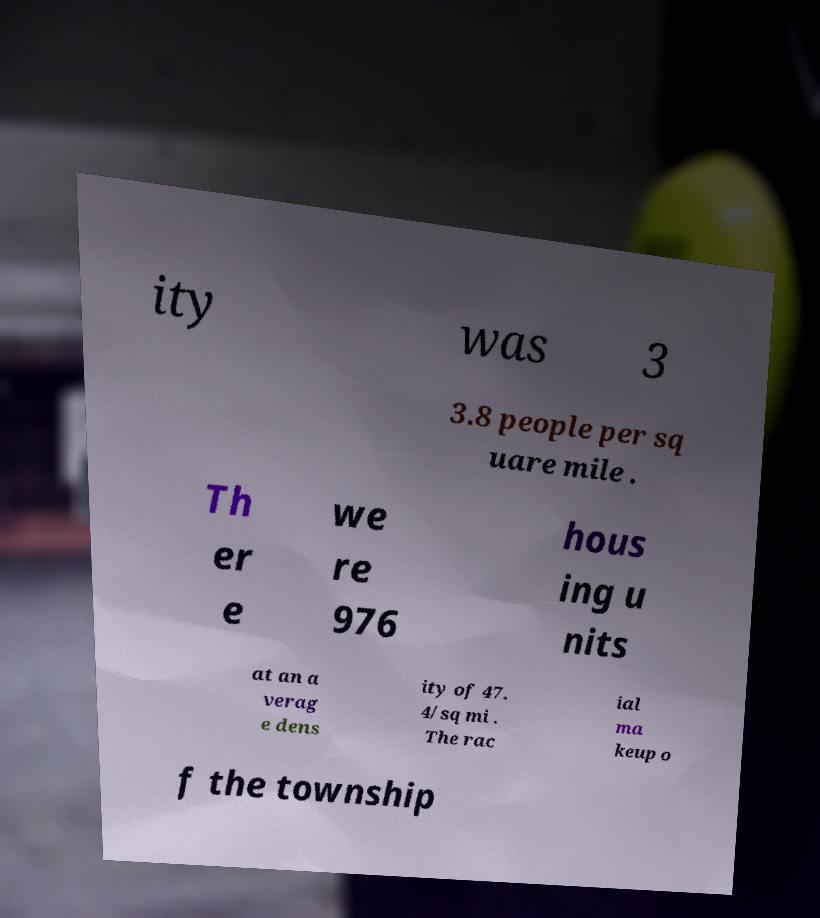Can you accurately transcribe the text from the provided image for me? ity was 3 3.8 people per sq uare mile . Th er e we re 976 hous ing u nits at an a verag e dens ity of 47. 4/sq mi . The rac ial ma keup o f the township 